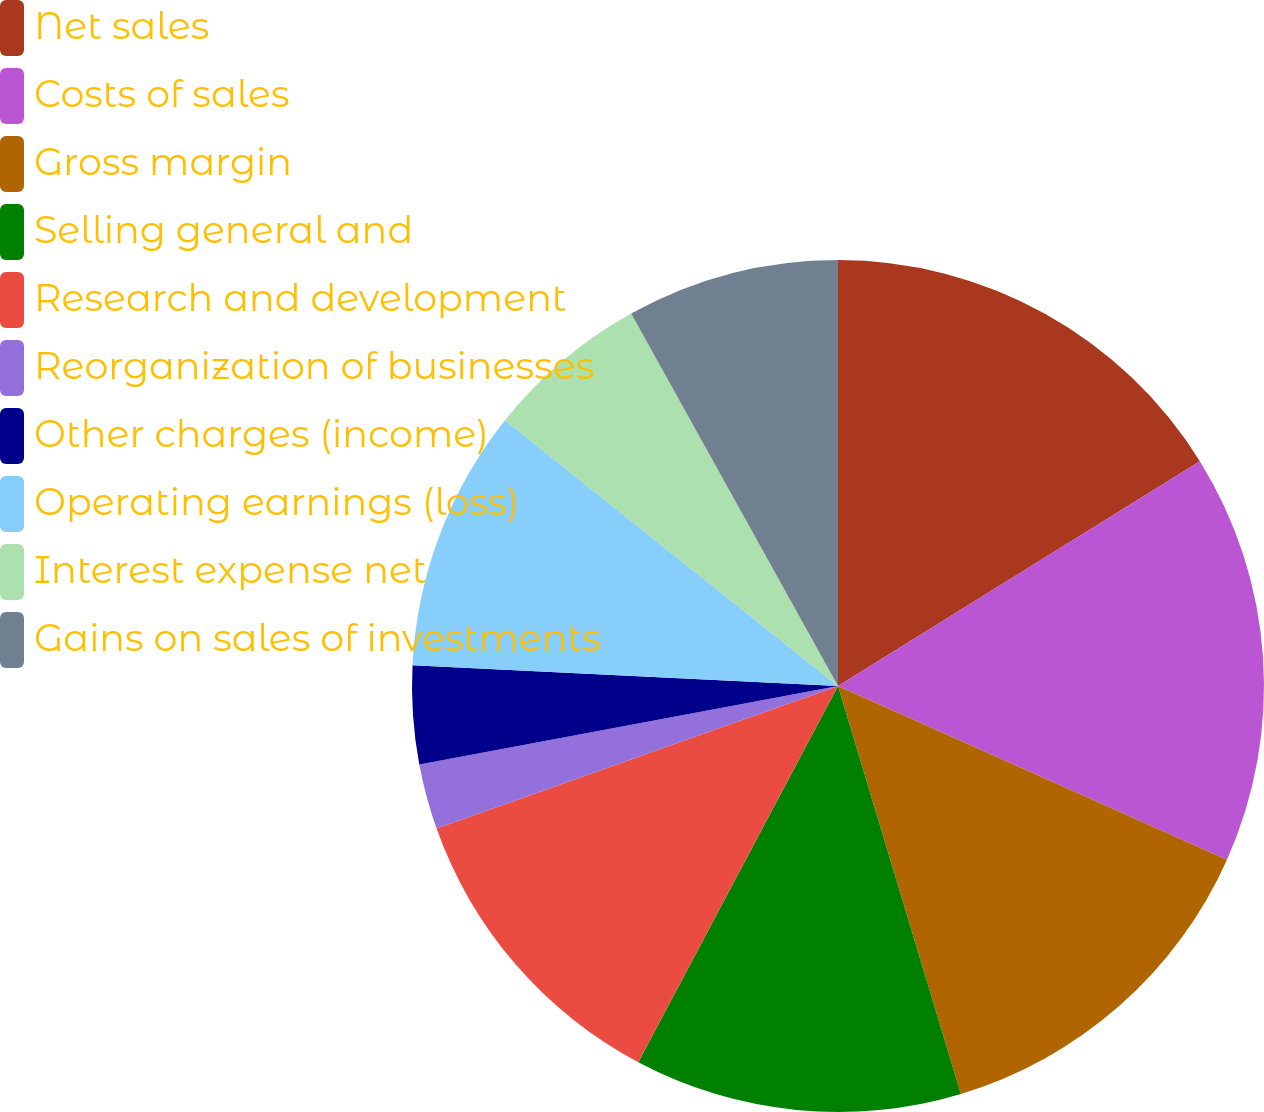Convert chart. <chart><loc_0><loc_0><loc_500><loc_500><pie_chart><fcel>Net sales<fcel>Costs of sales<fcel>Gross margin<fcel>Selling general and<fcel>Research and development<fcel>Reorganization of businesses<fcel>Other charges (income)<fcel>Operating earnings (loss)<fcel>Interest expense net<fcel>Gains on sales of investments<nl><fcel>16.15%<fcel>15.53%<fcel>13.66%<fcel>12.42%<fcel>11.8%<fcel>2.48%<fcel>3.73%<fcel>9.94%<fcel>6.21%<fcel>8.07%<nl></chart> 